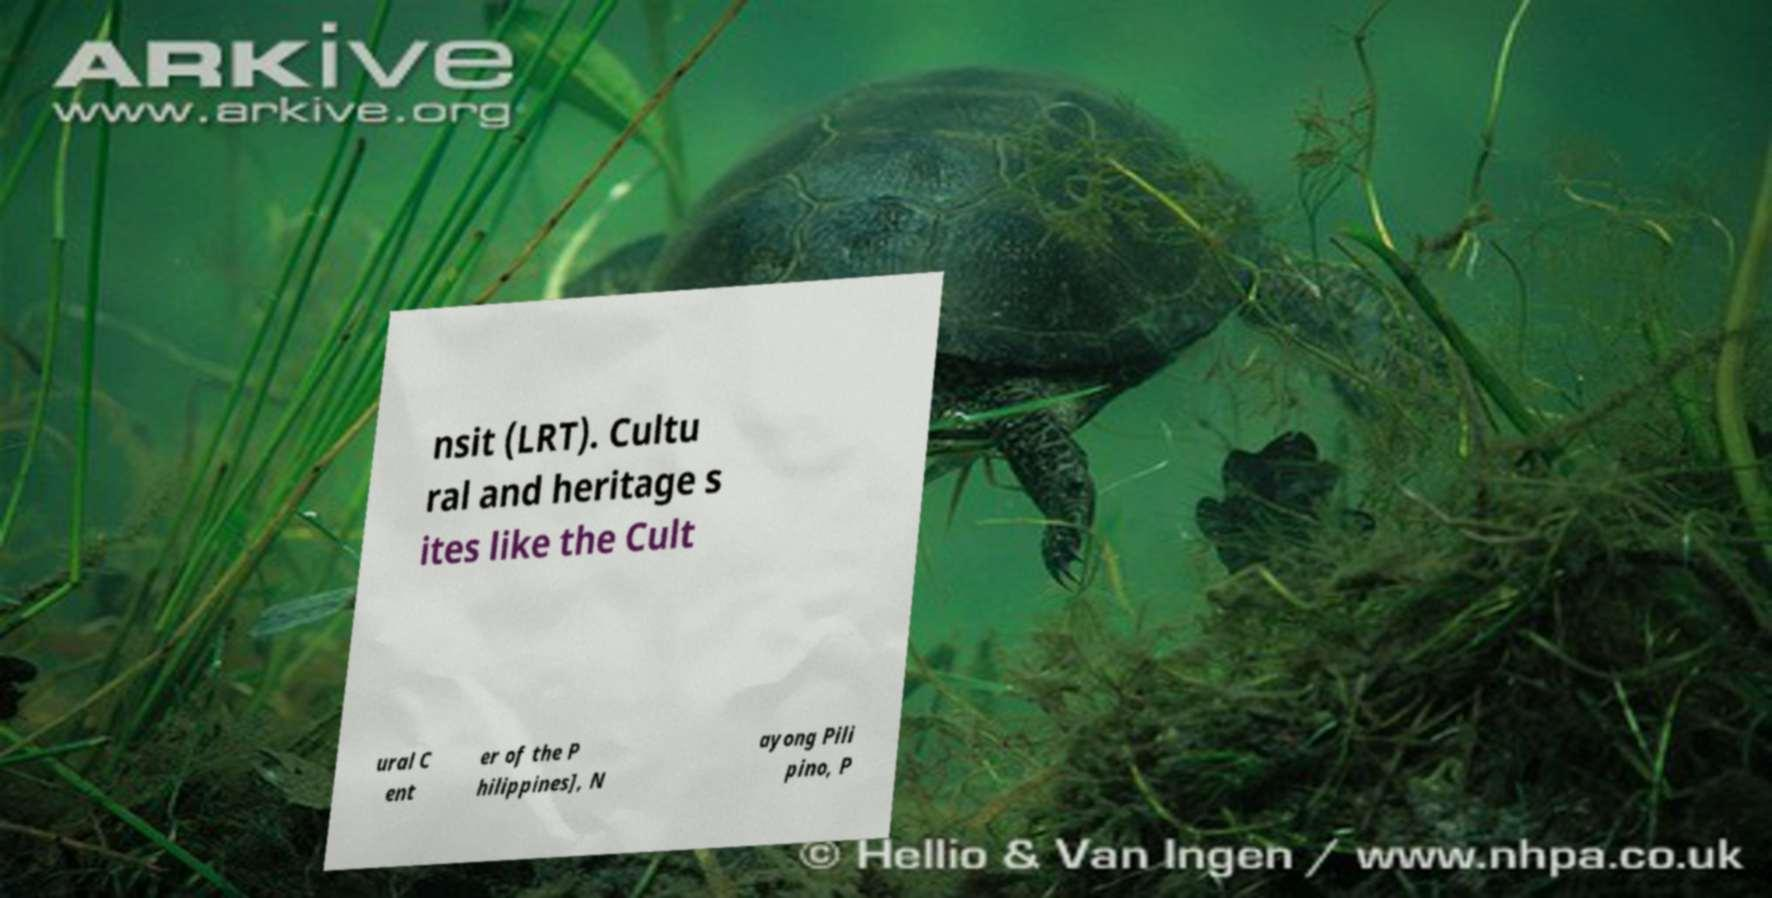For documentation purposes, I need the text within this image transcribed. Could you provide that? nsit (LRT). Cultu ral and heritage s ites like the Cult ural C ent er of the P hilippines], N ayong Pili pino, P 